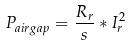<formula> <loc_0><loc_0><loc_500><loc_500>P _ { a i r g a p } = \frac { R _ { r } } { s } * I _ { r } ^ { 2 }</formula> 